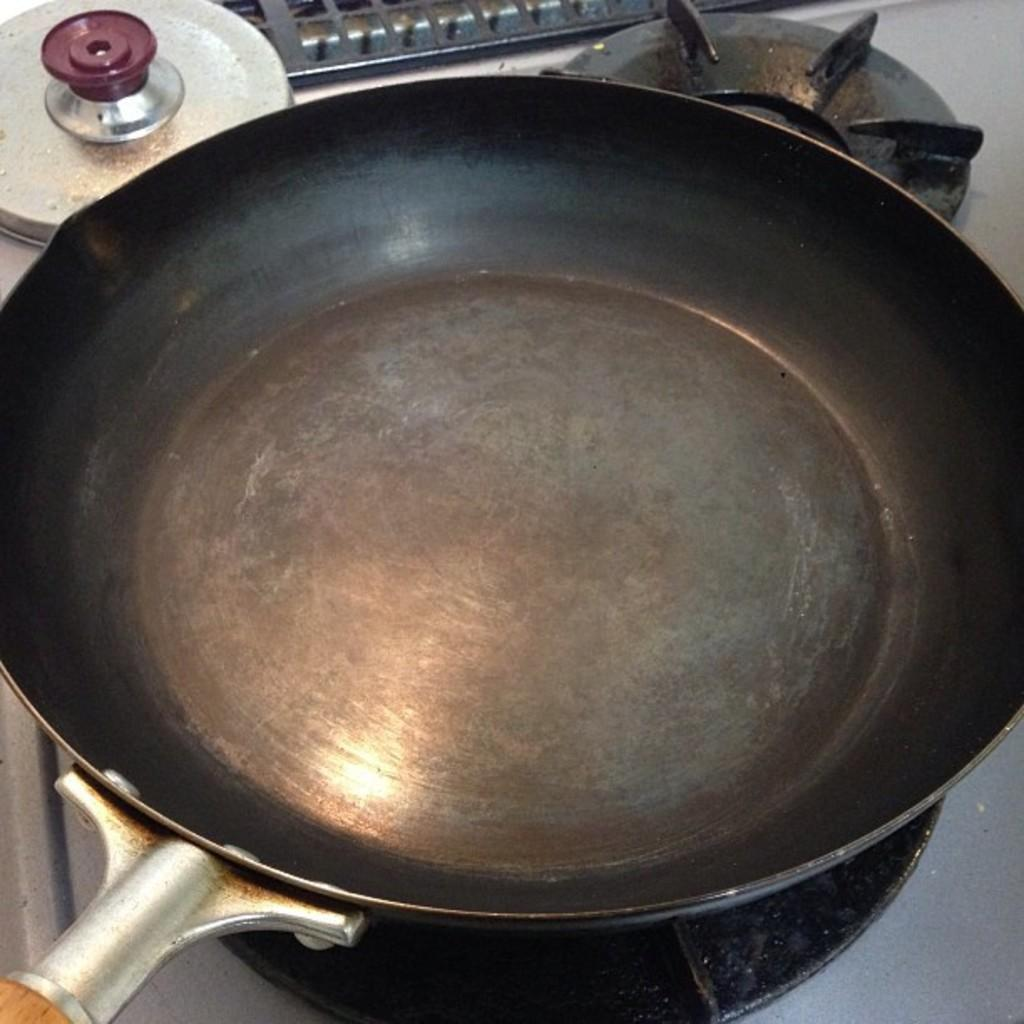What is the main object in the image? There is an empty pan in the image. Where is the pan located in the image? The pan is placed on a stove. What type of sea creature can be seen swimming in the pan in the image? There is no sea creature present in the image; it only shows an empty pan placed on a stove. 